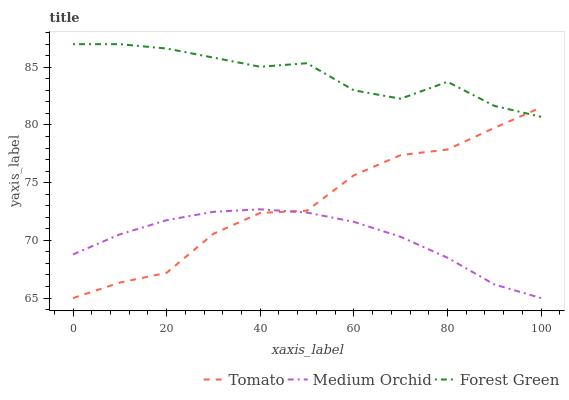Does Forest Green have the minimum area under the curve?
Answer yes or no. No. Does Medium Orchid have the maximum area under the curve?
Answer yes or no. No. Is Forest Green the smoothest?
Answer yes or no. No. Is Forest Green the roughest?
Answer yes or no. No. Does Forest Green have the lowest value?
Answer yes or no. No. Does Medium Orchid have the highest value?
Answer yes or no. No. Is Medium Orchid less than Forest Green?
Answer yes or no. Yes. Is Forest Green greater than Medium Orchid?
Answer yes or no. Yes. Does Medium Orchid intersect Forest Green?
Answer yes or no. No. 